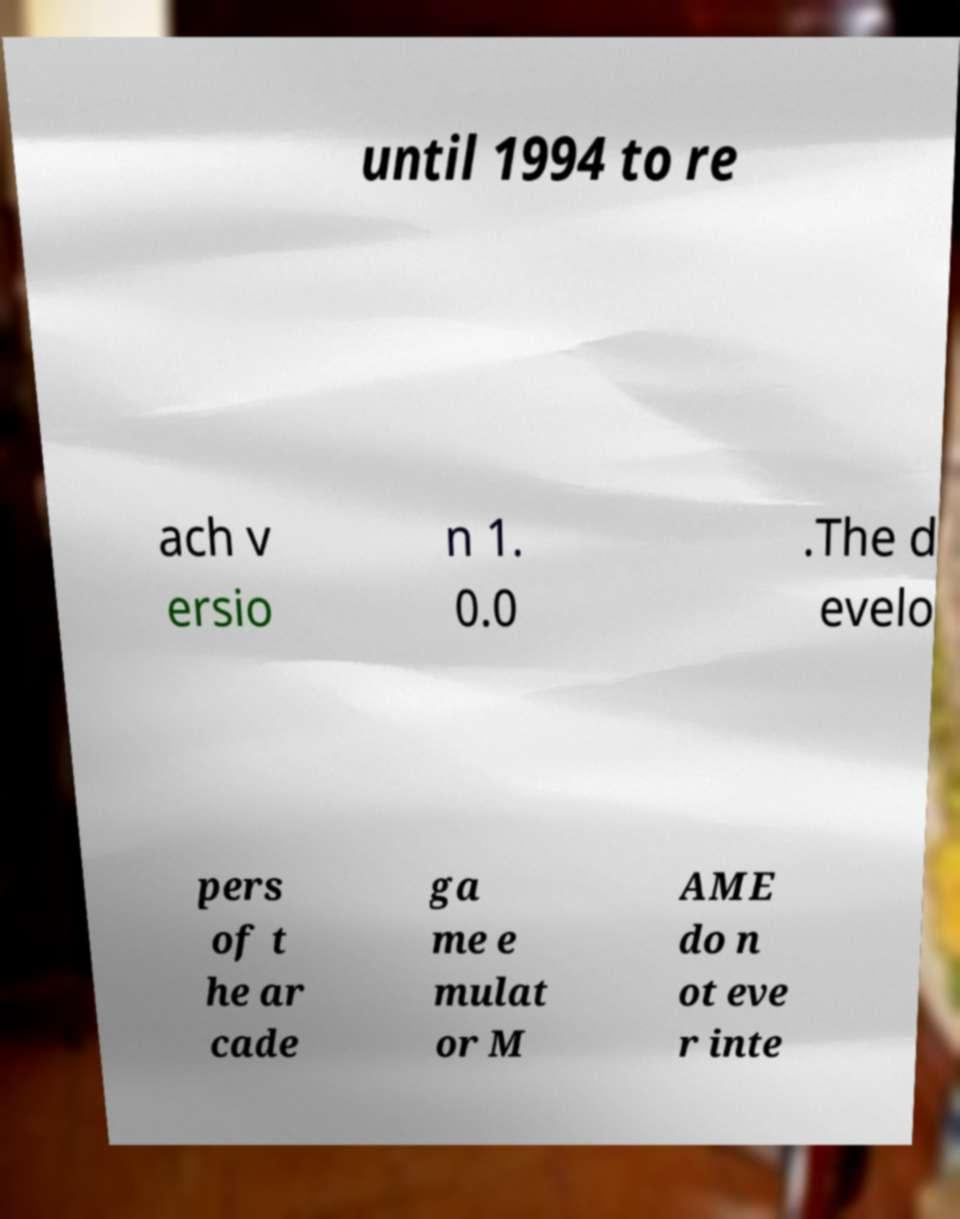For documentation purposes, I need the text within this image transcribed. Could you provide that? until 1994 to re ach v ersio n 1. 0.0 .The d evelo pers of t he ar cade ga me e mulat or M AME do n ot eve r inte 